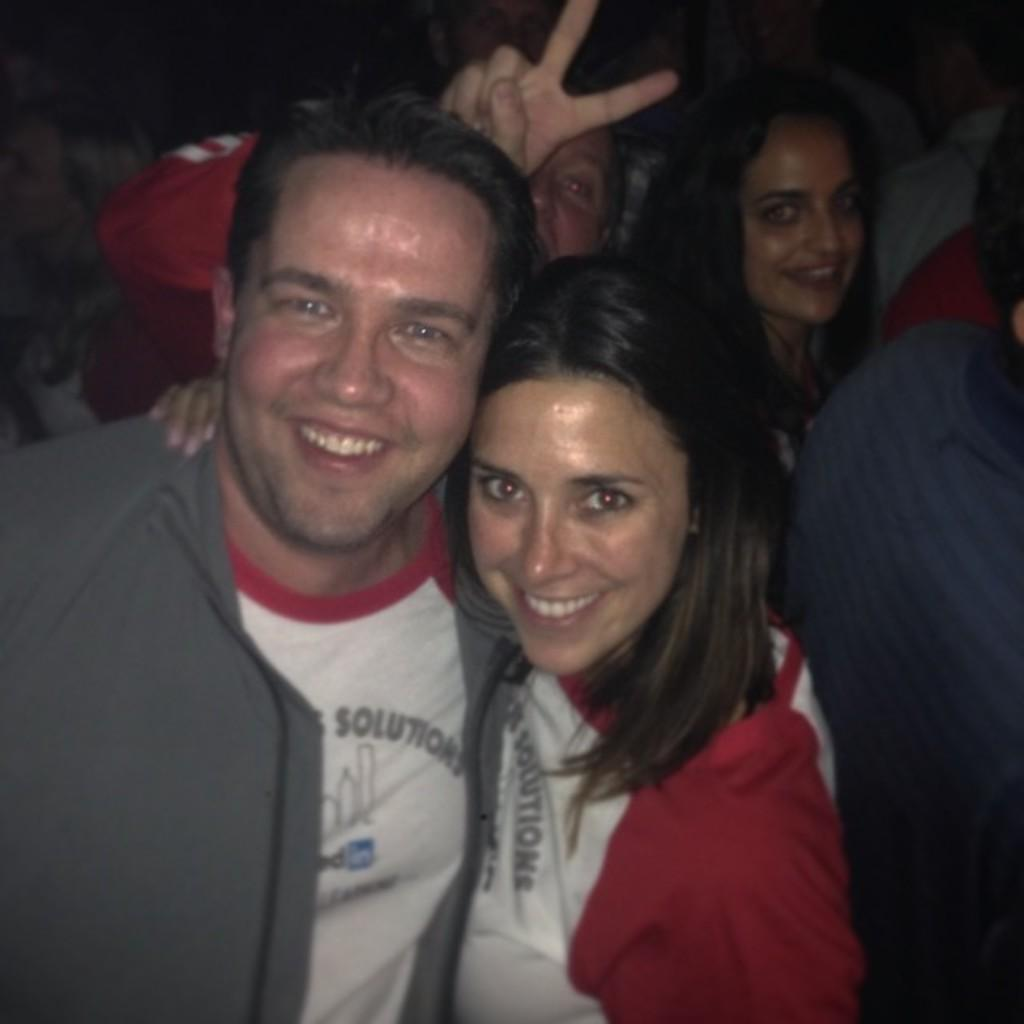How many people are present in the image? There are two people, a woman and a man, present in the image. What are the woman and the man doing in the image? Both the woman and the man are posing for a camera. What expressions do the woman and the man have in the image? The woman and the man are smiling in the image. Can you describe the background of the image? There are other persons visible in the background of the image. What type of plant is the beggar holding in the image? There is no beggar or plant present in the image. How many elbows can be seen in the image? The number of elbows cannot be determined from the image, as it only shows the woman and the man from the waist up. 